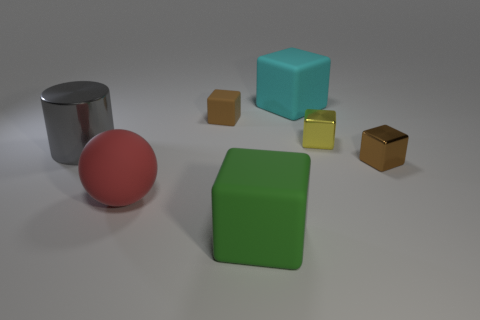Subtract all small brown matte blocks. How many blocks are left? 4 Subtract all brown blocks. How many blocks are left? 3 Subtract 1 cylinders. How many cylinders are left? 0 Add 1 large cyan metallic cubes. How many objects exist? 8 Subtract all blocks. How many objects are left? 2 Subtract all blue spheres. Subtract all purple cylinders. How many spheres are left? 1 Subtract all purple spheres. How many yellow blocks are left? 1 Subtract all matte cubes. Subtract all tiny green cubes. How many objects are left? 4 Add 6 big cyan things. How many big cyan things are left? 7 Add 1 big cylinders. How many big cylinders exist? 2 